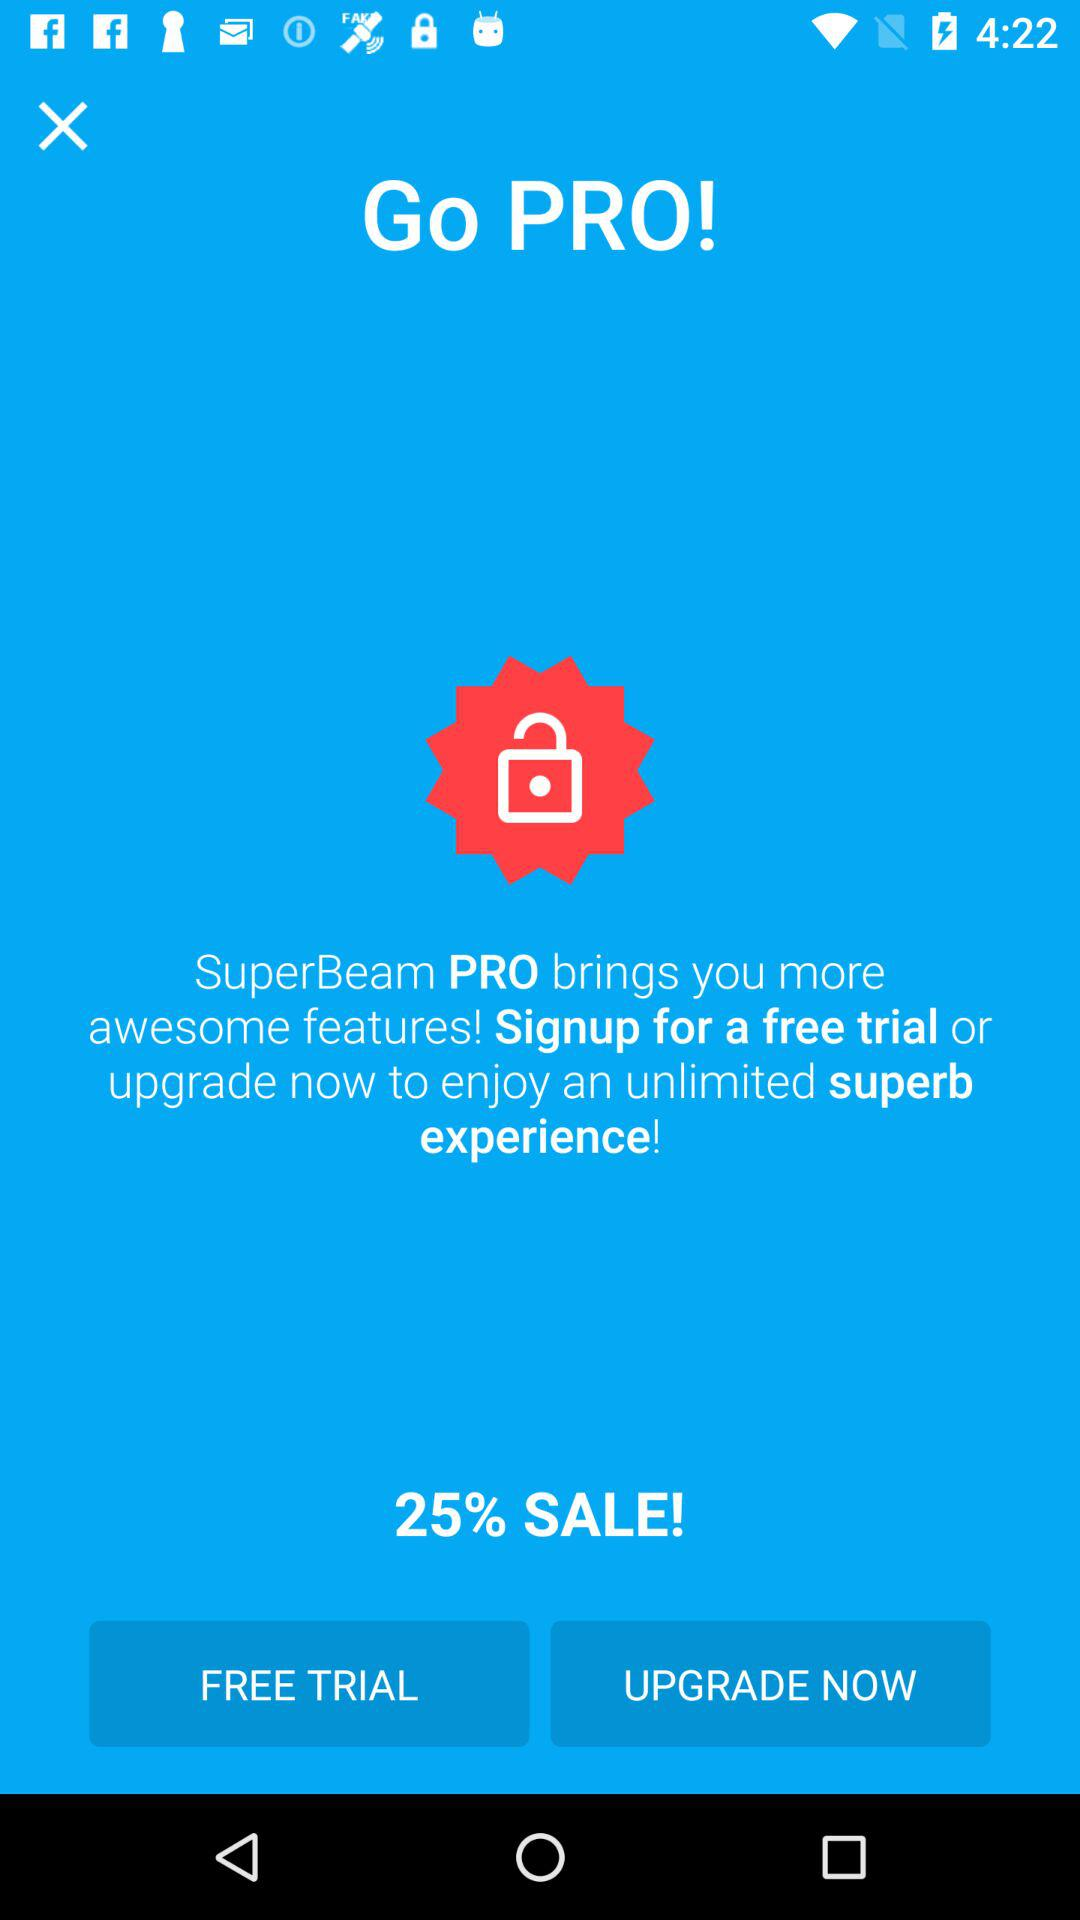How much is off on sale?
When the provided information is insufficient, respond with <no answer>. <no answer> 